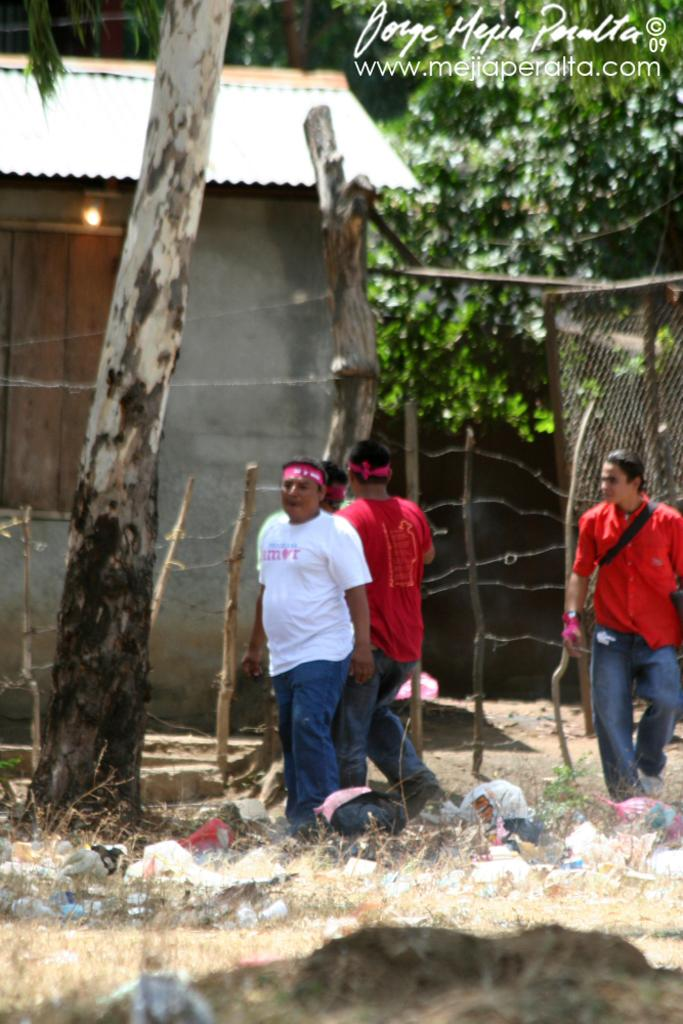How many people are present in the image? There are four people in the image. What are the people wearing? The people are wearing clothes. What type of vegetation can be seen in the image? There is dry grass and trees in the image. What structures are visible in the image? There is a tree trunk, a fence, a house, a light, a wooden pole, and a trash can in the image. What type of cattle can be seen grazing in the image? There are no cattle present in the image. How is the distribution of resources being discussed among the people in the image? There is no discussion taking place in the image, and therefore no discussion about the distribution of resources. 